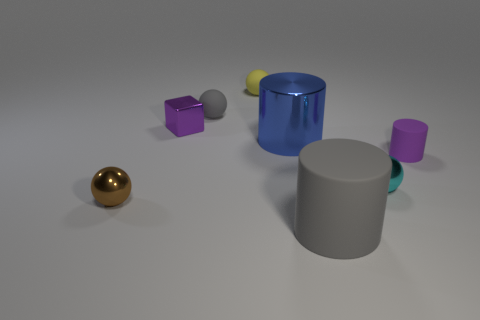There is a sphere that is the same color as the big rubber cylinder; what is its material?
Ensure brevity in your answer.  Rubber. Is there a object on the right side of the big object in front of the tiny purple rubber object behind the gray rubber cylinder?
Ensure brevity in your answer.  Yes. Does the purple object right of the yellow rubber sphere have the same material as the small ball in front of the small cyan metallic thing?
Offer a very short reply. No. What number of things are either brown matte cylinders or small objects right of the tiny purple block?
Make the answer very short. 4. What number of other tiny metallic things are the same shape as the blue metallic object?
Provide a succinct answer. 0. What is the material of the brown object that is the same size as the cyan sphere?
Keep it short and to the point. Metal. How big is the cylinder that is on the right side of the cylinder in front of the small cyan thing that is on the right side of the purple metal cube?
Offer a terse response. Small. Do the object in front of the small brown thing and the matte sphere that is to the left of the small yellow ball have the same color?
Provide a short and direct response. Yes. What number of gray things are either small rubber spheres or small cylinders?
Your answer should be very brief. 1. What number of gray things have the same size as the blue cylinder?
Your answer should be very brief. 1. 